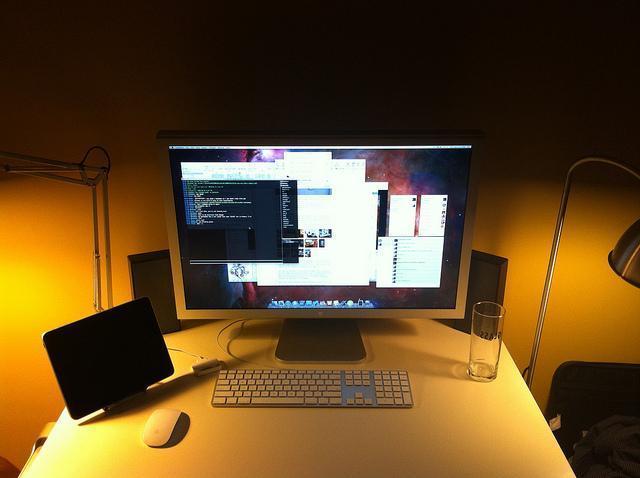How many tvs are there?
Give a very brief answer. 2. 